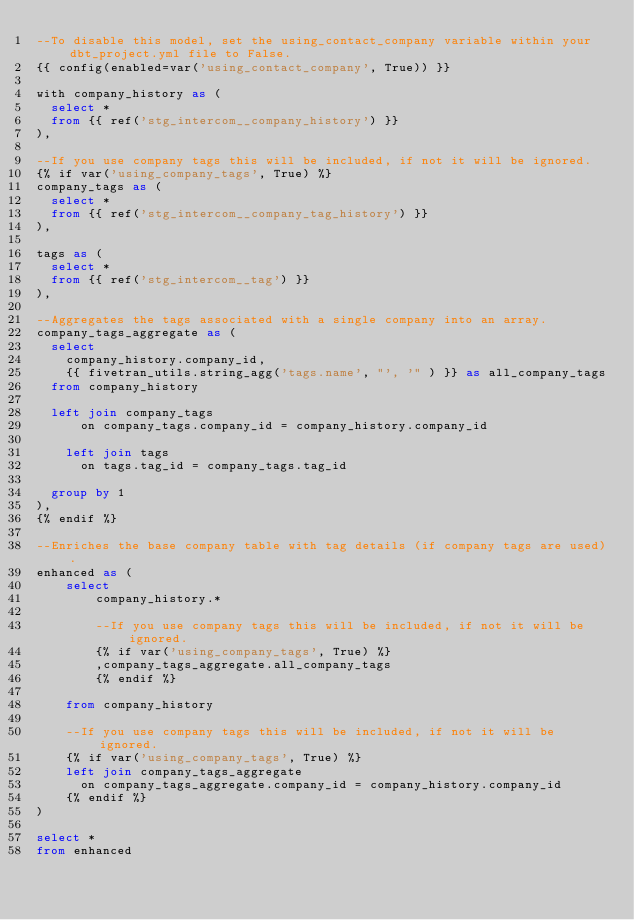<code> <loc_0><loc_0><loc_500><loc_500><_SQL_>--To disable this model, set the using_contact_company variable within your dbt_project.yml file to False.
{{ config(enabled=var('using_contact_company', True)) }}

with company_history as (
  select *
  from {{ ref('stg_intercom__company_history') }}
),

--If you use company tags this will be included, if not it will be ignored.
{% if var('using_company_tags', True) %}
company_tags as (
  select *
  from {{ ref('stg_intercom__company_tag_history') }}
),

tags as (
  select *
  from {{ ref('stg_intercom__tag') }}
),

--Aggregates the tags associated with a single company into an array.
company_tags_aggregate as (
  select
    company_history.company_id,
    {{ fivetran_utils.string_agg('tags.name', "', '" ) }} as all_company_tags
  from company_history

  left join company_tags
      on company_tags.company_id = company_history.company_id
    
    left join tags
      on tags.tag_id = company_tags.tag_id

  group by 1
),
{% endif %}

--Enriches the base company table with tag details (if company tags are used).
enhanced as (
    select
        company_history.*

        --If you use company tags this will be included, if not it will be ignored.
        {% if var('using_company_tags', True) %}
        ,company_tags_aggregate.all_company_tags
        {% endif %}

    from company_history

    --If you use company tags this will be included, if not it will be ignored.
    {% if var('using_company_tags', True) %}
    left join company_tags_aggregate
      on company_tags_aggregate.company_id = company_history.company_id
    {% endif %}
)

select * 
from enhanced</code> 